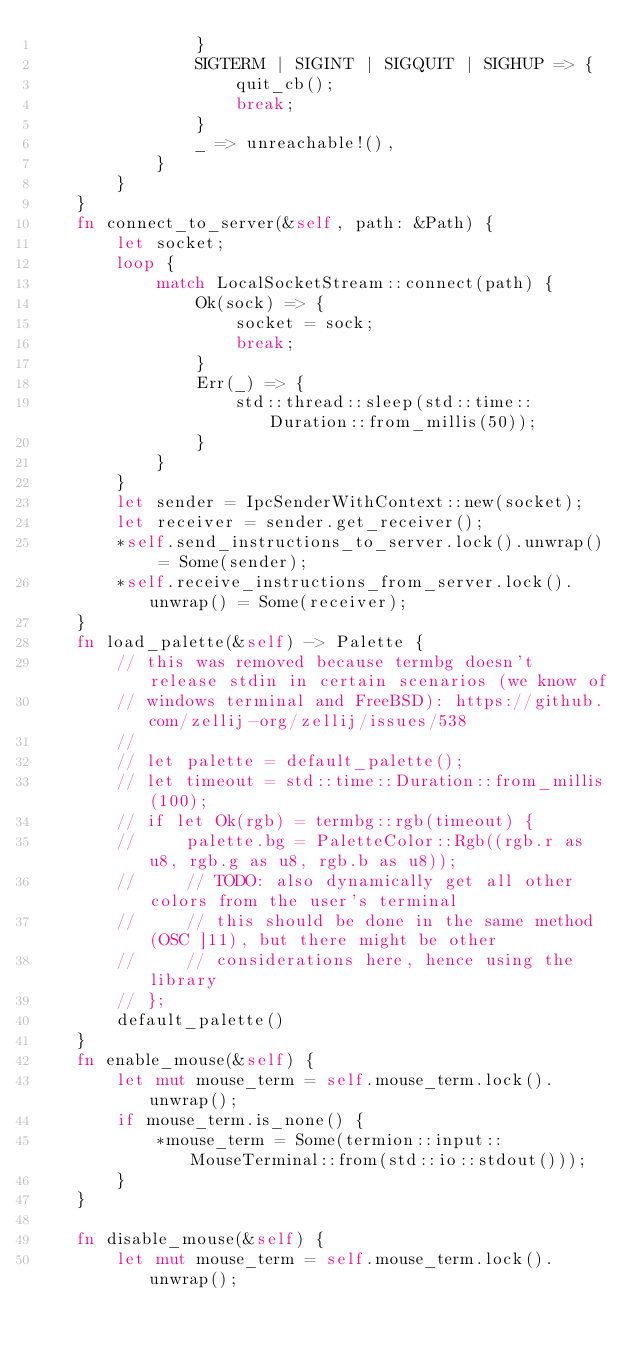Convert code to text. <code><loc_0><loc_0><loc_500><loc_500><_Rust_>                }
                SIGTERM | SIGINT | SIGQUIT | SIGHUP => {
                    quit_cb();
                    break;
                }
                _ => unreachable!(),
            }
        }
    }
    fn connect_to_server(&self, path: &Path) {
        let socket;
        loop {
            match LocalSocketStream::connect(path) {
                Ok(sock) => {
                    socket = sock;
                    break;
                }
                Err(_) => {
                    std::thread::sleep(std::time::Duration::from_millis(50));
                }
            }
        }
        let sender = IpcSenderWithContext::new(socket);
        let receiver = sender.get_receiver();
        *self.send_instructions_to_server.lock().unwrap() = Some(sender);
        *self.receive_instructions_from_server.lock().unwrap() = Some(receiver);
    }
    fn load_palette(&self) -> Palette {
        // this was removed because termbg doesn't release stdin in certain scenarios (we know of
        // windows terminal and FreeBSD): https://github.com/zellij-org/zellij/issues/538
        //
        // let palette = default_palette();
        // let timeout = std::time::Duration::from_millis(100);
        // if let Ok(rgb) = termbg::rgb(timeout) {
        //     palette.bg = PaletteColor::Rgb((rgb.r as u8, rgb.g as u8, rgb.b as u8));
        //     // TODO: also dynamically get all other colors from the user's terminal
        //     // this should be done in the same method (OSC ]11), but there might be other
        //     // considerations here, hence using the library
        // };
        default_palette()
    }
    fn enable_mouse(&self) {
        let mut mouse_term = self.mouse_term.lock().unwrap();
        if mouse_term.is_none() {
            *mouse_term = Some(termion::input::MouseTerminal::from(std::io::stdout()));
        }
    }

    fn disable_mouse(&self) {
        let mut mouse_term = self.mouse_term.lock().unwrap();</code> 